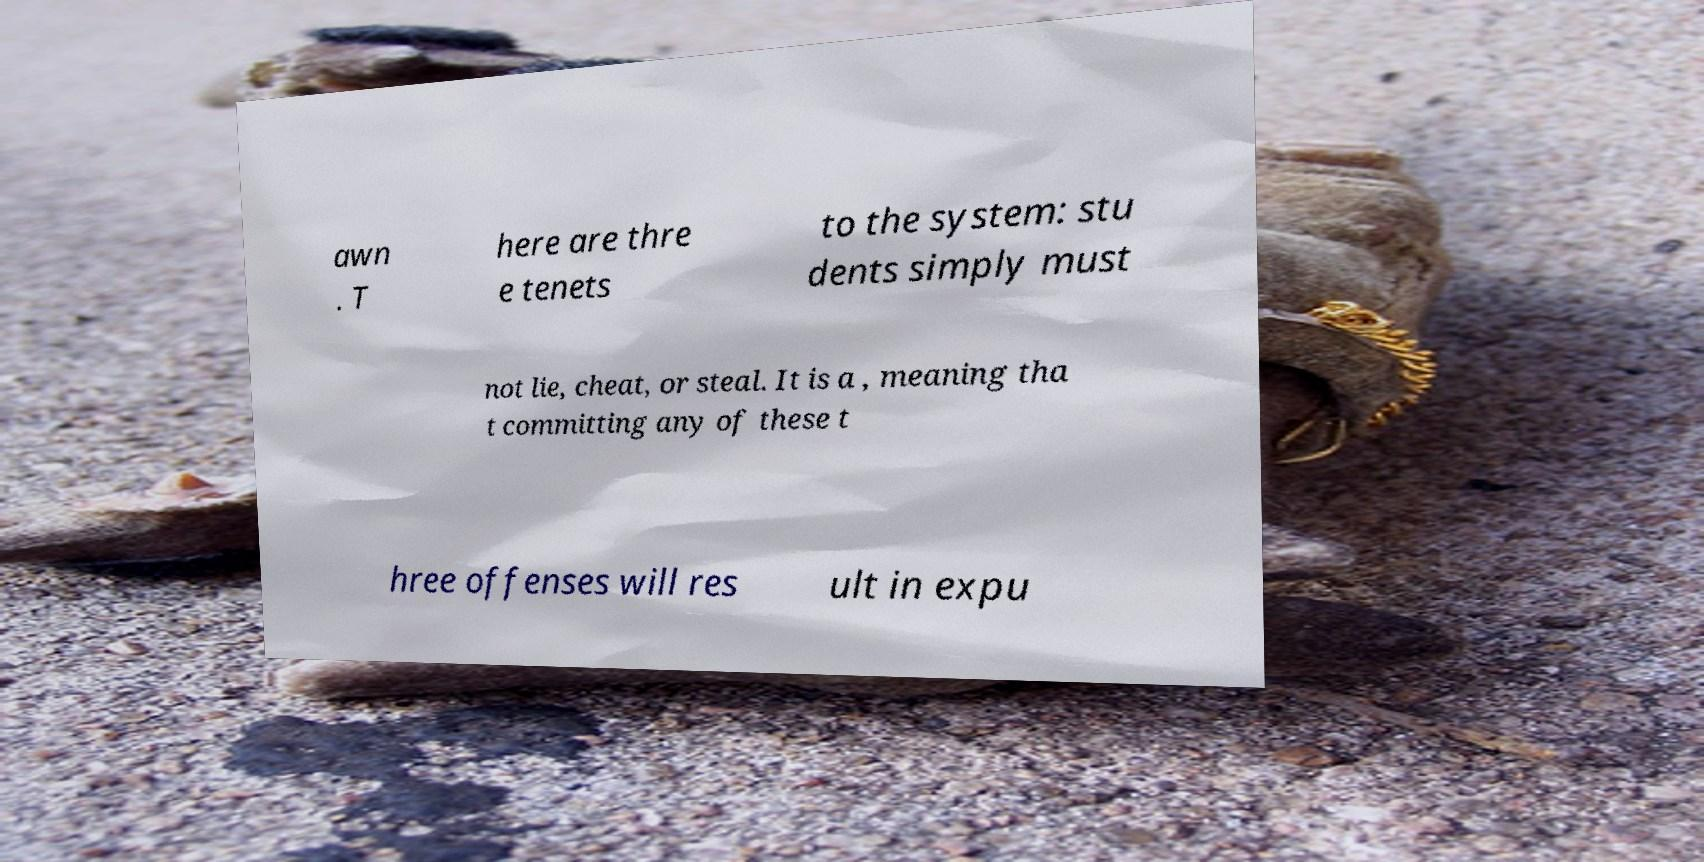Please read and relay the text visible in this image. What does it say? awn . T here are thre e tenets to the system: stu dents simply must not lie, cheat, or steal. It is a , meaning tha t committing any of these t hree offenses will res ult in expu 